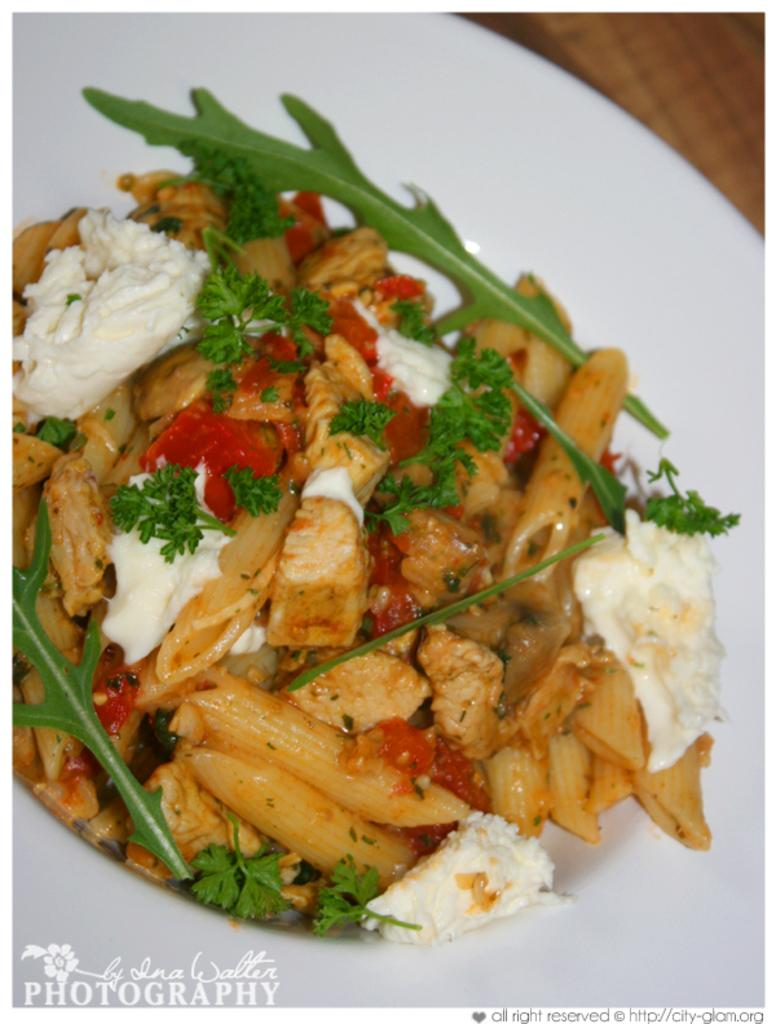What is on the plate that is in the middle of the image? There is a food item on a white color plate in the image. Can you describe the location of the plate in the image? The plate is in the middle of the image. What additional detail can be observed at the bottom of the image? There is a logo present at the bottom of the image. How many balloons are floating above the food item in the image? There are no balloons present in the image. Is there a baby holding a rifle in the image? There is no baby or rifle present in the image. 